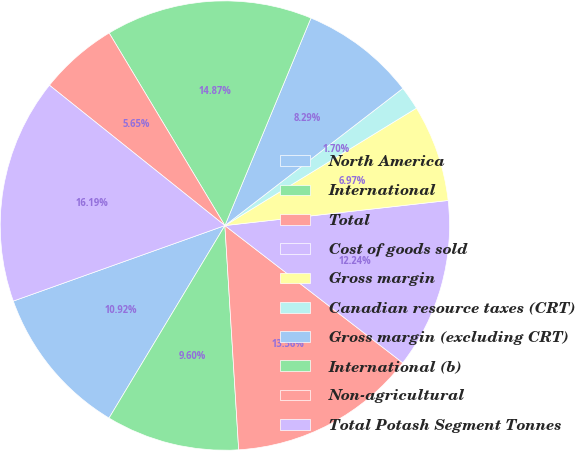Convert chart. <chart><loc_0><loc_0><loc_500><loc_500><pie_chart><fcel>North America<fcel>International<fcel>Total<fcel>Cost of goods sold<fcel>Gross margin<fcel>Canadian resource taxes (CRT)<fcel>Gross margin (excluding CRT)<fcel>International (b)<fcel>Non-agricultural<fcel>Total Potash Segment Tonnes<nl><fcel>10.92%<fcel>9.6%<fcel>13.56%<fcel>12.24%<fcel>6.97%<fcel>1.7%<fcel>8.29%<fcel>14.87%<fcel>5.65%<fcel>16.19%<nl></chart> 